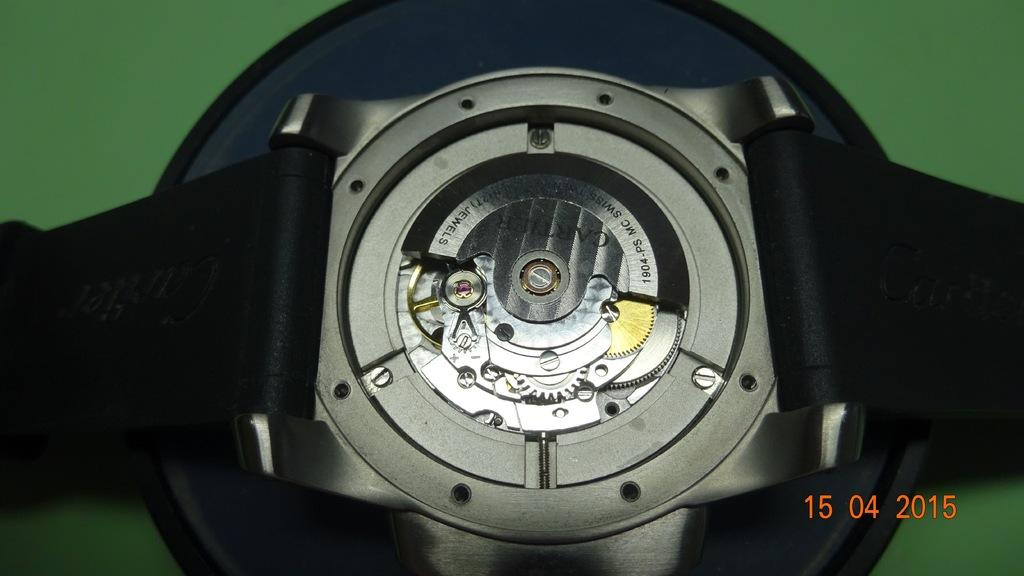<image>
Render a clear and concise summary of the photo. The backing of a Cartier wrist watch is removed so that all the inside mechanics are visible in a photo taken on April 15, 2015. 